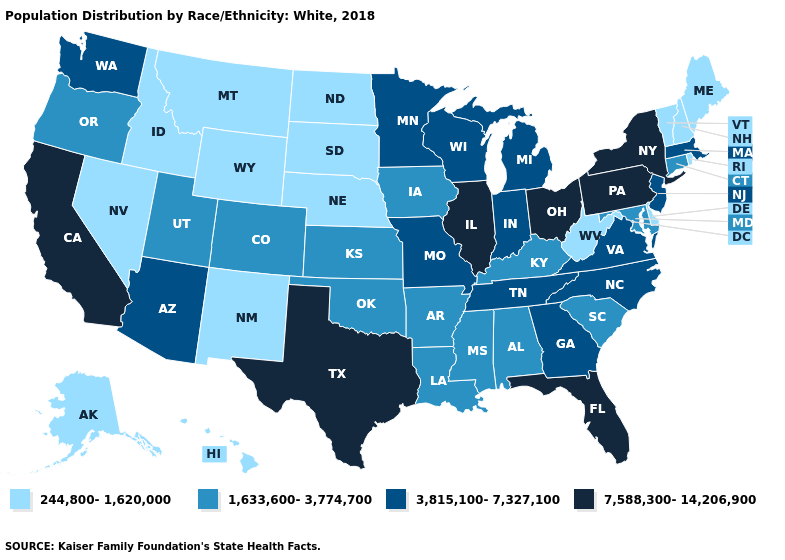What is the value of Colorado?
Concise answer only. 1,633,600-3,774,700. Name the states that have a value in the range 1,633,600-3,774,700?
Be succinct. Alabama, Arkansas, Colorado, Connecticut, Iowa, Kansas, Kentucky, Louisiana, Maryland, Mississippi, Oklahoma, Oregon, South Carolina, Utah. What is the value of West Virginia?
Short answer required. 244,800-1,620,000. Which states have the highest value in the USA?
Give a very brief answer. California, Florida, Illinois, New York, Ohio, Pennsylvania, Texas. Name the states that have a value in the range 3,815,100-7,327,100?
Be succinct. Arizona, Georgia, Indiana, Massachusetts, Michigan, Minnesota, Missouri, New Jersey, North Carolina, Tennessee, Virginia, Washington, Wisconsin. Does Nevada have the highest value in the USA?
Give a very brief answer. No. What is the value of Oregon?
Short answer required. 1,633,600-3,774,700. Name the states that have a value in the range 1,633,600-3,774,700?
Answer briefly. Alabama, Arkansas, Colorado, Connecticut, Iowa, Kansas, Kentucky, Louisiana, Maryland, Mississippi, Oklahoma, Oregon, South Carolina, Utah. Does Ohio have a lower value than Wyoming?
Keep it brief. No. Name the states that have a value in the range 3,815,100-7,327,100?
Short answer required. Arizona, Georgia, Indiana, Massachusetts, Michigan, Minnesota, Missouri, New Jersey, North Carolina, Tennessee, Virginia, Washington, Wisconsin. Name the states that have a value in the range 244,800-1,620,000?
Concise answer only. Alaska, Delaware, Hawaii, Idaho, Maine, Montana, Nebraska, Nevada, New Hampshire, New Mexico, North Dakota, Rhode Island, South Dakota, Vermont, West Virginia, Wyoming. What is the lowest value in states that border Maine?
Write a very short answer. 244,800-1,620,000. Does Rhode Island have the lowest value in the USA?
Concise answer only. Yes. Among the states that border Kansas , does Missouri have the highest value?
Concise answer only. Yes. Among the states that border Kentucky , does Indiana have the lowest value?
Write a very short answer. No. 